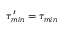<formula> <loc_0><loc_0><loc_500><loc_500>\tau _ { \min } ^ { \prime } = \tau _ { \min }</formula> 